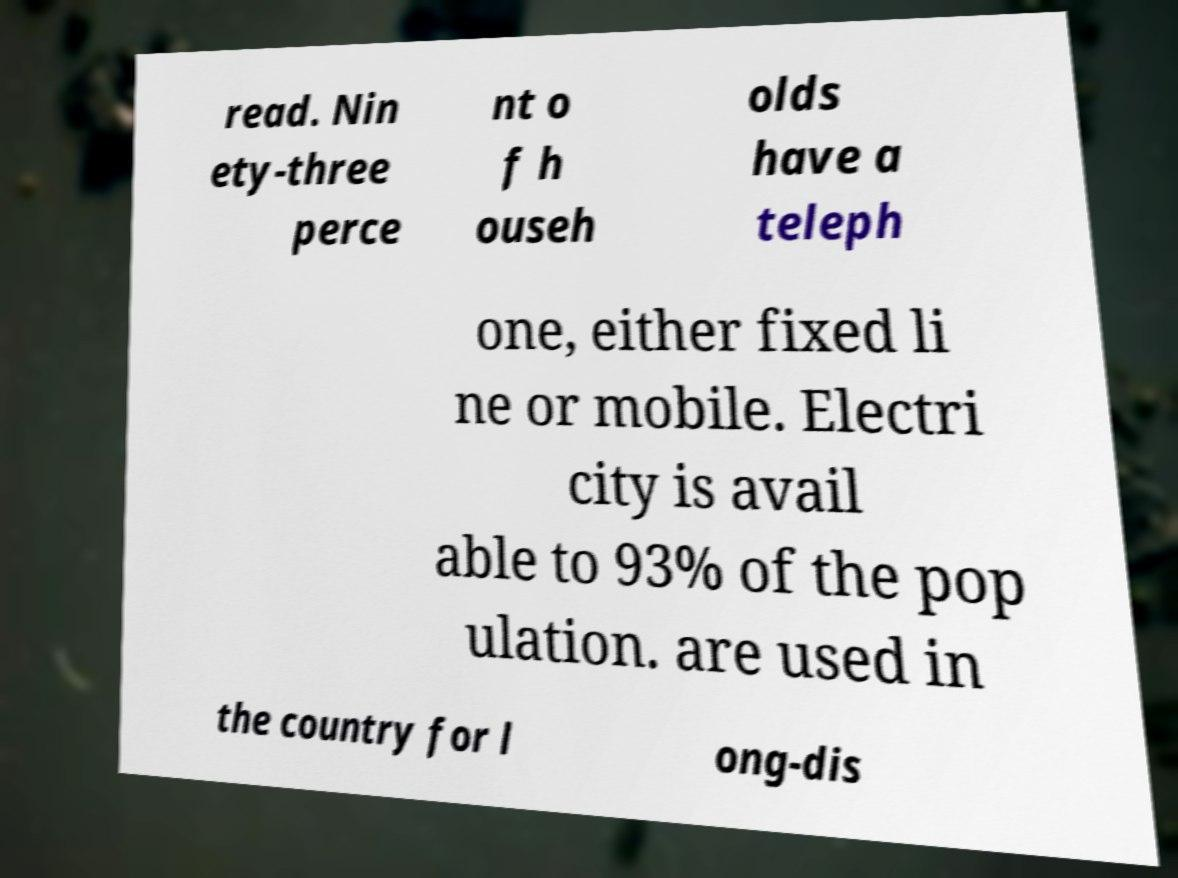Please identify and transcribe the text found in this image. read. Nin ety-three perce nt o f h ouseh olds have a teleph one, either fixed li ne or mobile. Electri city is avail able to 93% of the pop ulation. are used in the country for l ong-dis 